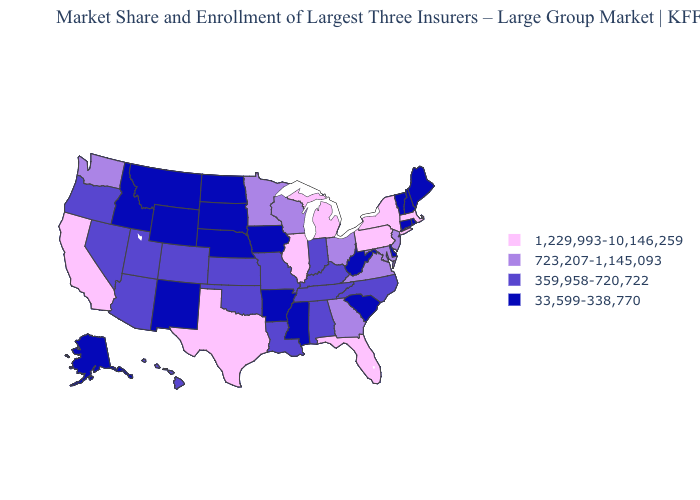What is the value of Hawaii?
Be succinct. 359,958-720,722. Which states have the highest value in the USA?
Be succinct. California, Florida, Illinois, Massachusetts, Michigan, New York, Pennsylvania, Texas. Name the states that have a value in the range 359,958-720,722?
Short answer required. Alabama, Arizona, Colorado, Hawaii, Indiana, Kansas, Kentucky, Louisiana, Missouri, Nevada, North Carolina, Oklahoma, Oregon, Tennessee, Utah. Name the states that have a value in the range 359,958-720,722?
Keep it brief. Alabama, Arizona, Colorado, Hawaii, Indiana, Kansas, Kentucky, Louisiana, Missouri, Nevada, North Carolina, Oklahoma, Oregon, Tennessee, Utah. What is the lowest value in the USA?
Answer briefly. 33,599-338,770. Which states have the lowest value in the Northeast?
Keep it brief. Connecticut, Maine, New Hampshire, Rhode Island, Vermont. Among the states that border Pennsylvania , does New York have the highest value?
Keep it brief. Yes. Does Montana have the lowest value in the West?
Keep it brief. Yes. What is the value of Montana?
Concise answer only. 33,599-338,770. Name the states that have a value in the range 359,958-720,722?
Short answer required. Alabama, Arizona, Colorado, Hawaii, Indiana, Kansas, Kentucky, Louisiana, Missouri, Nevada, North Carolina, Oklahoma, Oregon, Tennessee, Utah. Name the states that have a value in the range 1,229,993-10,146,259?
Answer briefly. California, Florida, Illinois, Massachusetts, Michigan, New York, Pennsylvania, Texas. Name the states that have a value in the range 1,229,993-10,146,259?
Concise answer only. California, Florida, Illinois, Massachusetts, Michigan, New York, Pennsylvania, Texas. Name the states that have a value in the range 33,599-338,770?
Quick response, please. Alaska, Arkansas, Connecticut, Delaware, Idaho, Iowa, Maine, Mississippi, Montana, Nebraska, New Hampshire, New Mexico, North Dakota, Rhode Island, South Carolina, South Dakota, Vermont, West Virginia, Wyoming. Name the states that have a value in the range 1,229,993-10,146,259?
Keep it brief. California, Florida, Illinois, Massachusetts, Michigan, New York, Pennsylvania, Texas. Does the first symbol in the legend represent the smallest category?
Give a very brief answer. No. 